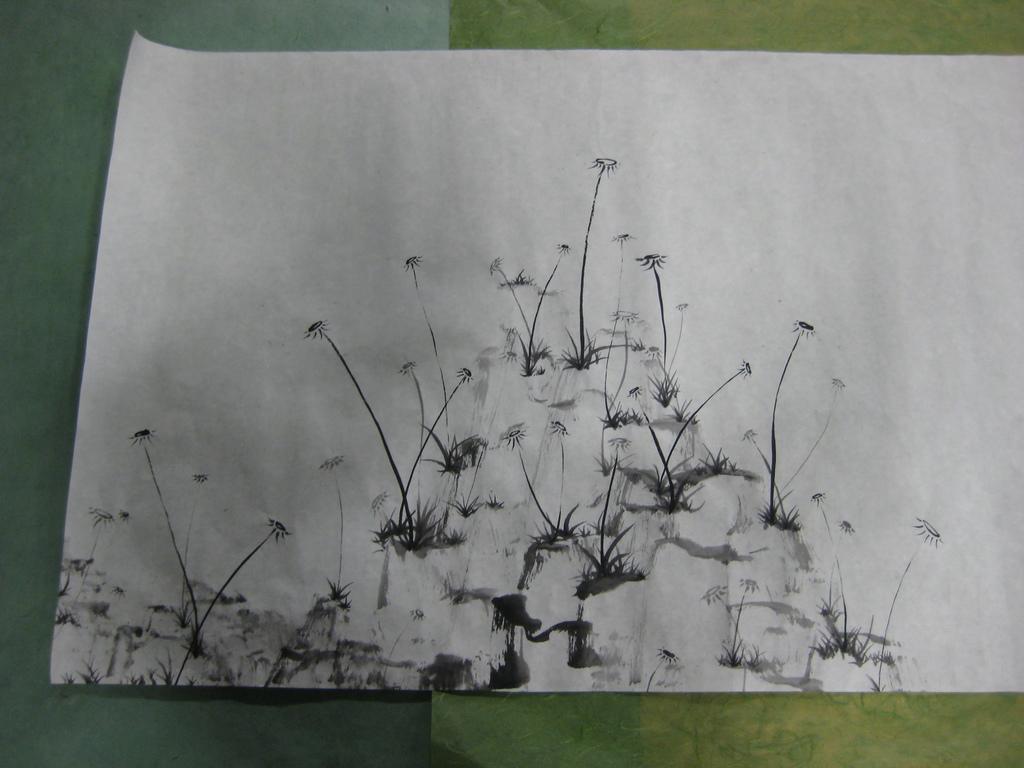Could you give a brief overview of what you see in this image? In this image, we can see a white poster pasted on the wall. 